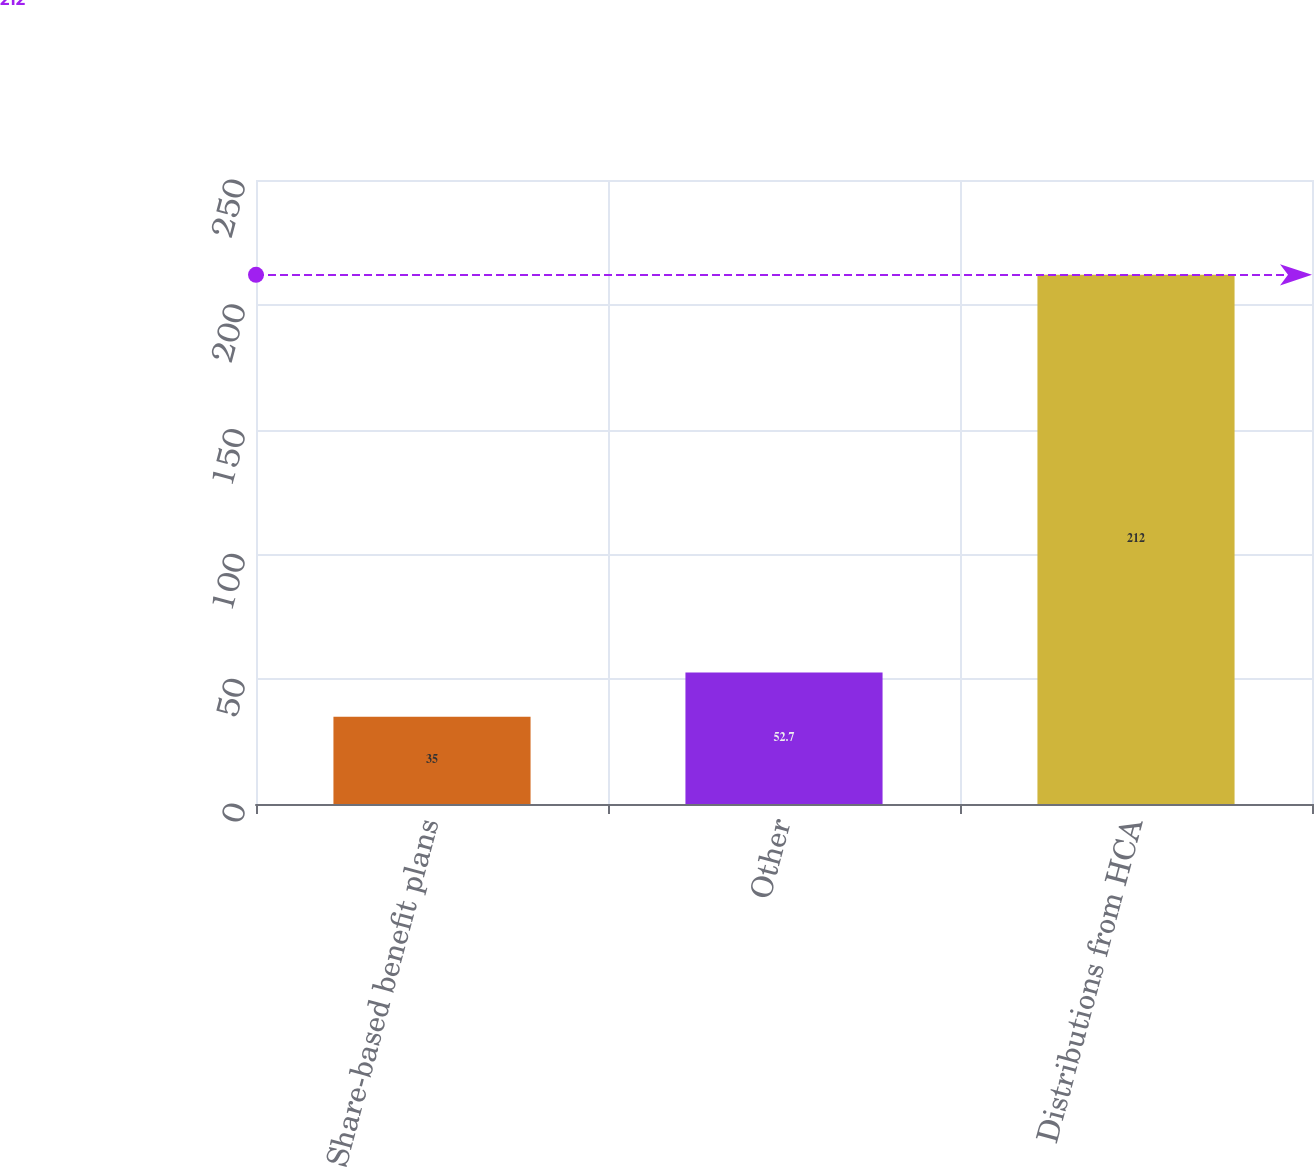<chart> <loc_0><loc_0><loc_500><loc_500><bar_chart><fcel>Share-based benefit plans<fcel>Other<fcel>Distributions from HCA<nl><fcel>35<fcel>52.7<fcel>212<nl></chart> 